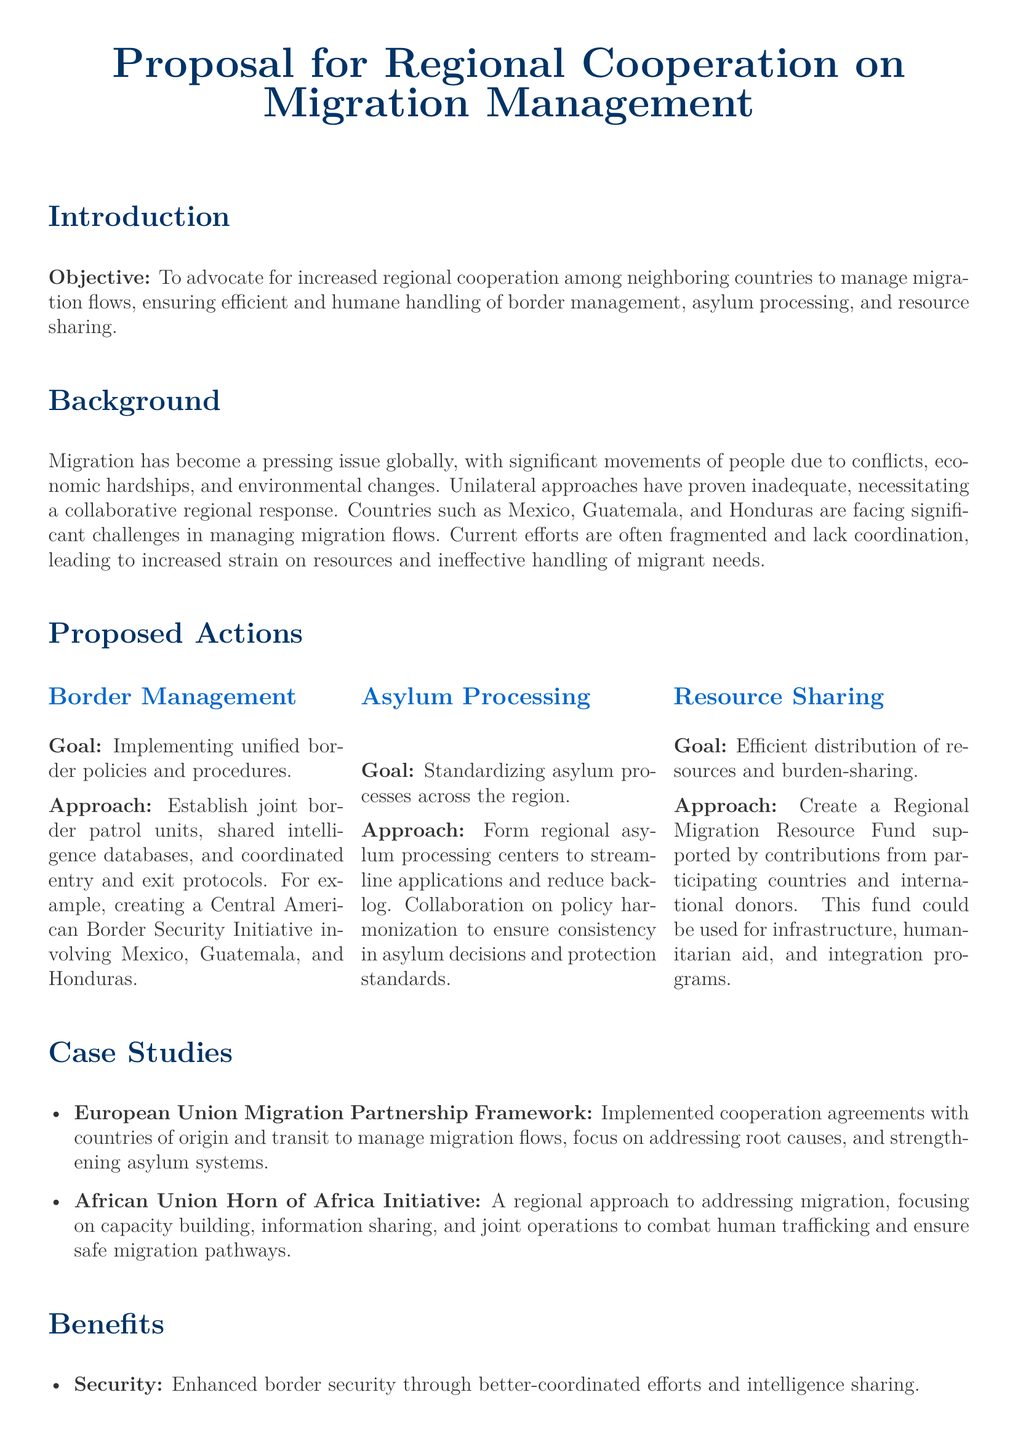What is the main objective of the proposal? The objective outlined in the document is focused on advocating for increased regional cooperation among neighboring countries to manage migration flows effectively.
Answer: increased regional cooperation What countries are mentioned as facing significant challenges in managing migration flows? The document specifically mentions Mexico, Guatemala, and Honduras as countries facing challenges related to migration.
Answer: Mexico, Guatemala, Honduras What is one of the proposed actions for border management? The document discusses establishing joint border patrol units as a measure for effective border management.
Answer: joint border patrol units What does the Regional Migration Resource Fund aim to support? The fund is intended to be used for infrastructure, humanitarian aid, and integration programs according to the proposed actions.
Answer: infrastructure, humanitarian aid, integration programs What is a goal of standardizing asylum processes? The goal of standardizing asylum processes is to streamline applications and reduce backlog in the region.
Answer: streamline applications, reduce backlog What case study is cited as an example of a regional approach to migration? The European Union Migration Partnership Framework is referenced as a case study demonstrating regional cooperation in migration management.
Answer: European Union Migration Partnership Framework What benefit is associated with enhanced border security? Enhanced border security is linked to better-coordinated efforts and intelligence sharing among countries.
Answer: better-coordinated efforts, intelligence sharing How does the document classify the approach to handling migration challenges? The approach is classified as collaborative, emphasizing that regional cooperation can transform migration into an opportunity.
Answer: collaborative, opportunity 